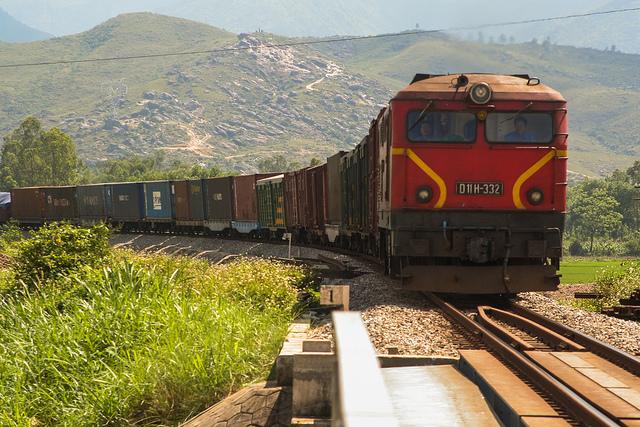What number is on the front of the bus?
Give a very brief answer. 332. Is this train traveling through an urban area?
Write a very short answer. No. Is the train on the tracks?
Quick response, please. Yes. 